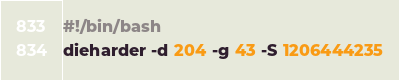Convert code to text. <code><loc_0><loc_0><loc_500><loc_500><_Bash_>#!/bin/bash
dieharder -d 204 -g 43 -S 1206444235
</code> 